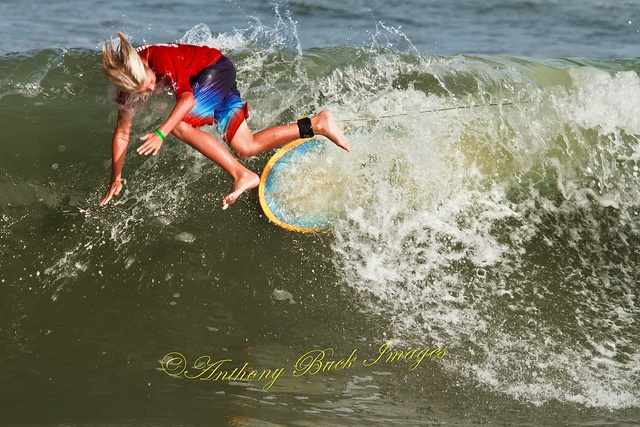Describe the objects in this image and their specific colors. I can see people in gray, salmon, brown, maroon, and black tones and surfboard in gray, beige, darkgray, lightgray, and tan tones in this image. 